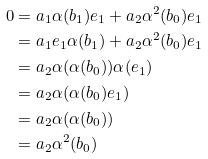<formula> <loc_0><loc_0><loc_500><loc_500>0 & = a _ { 1 } \alpha ( b _ { 1 } ) e _ { 1 } + a _ { 2 } \alpha ^ { 2 } ( b _ { 0 } ) e _ { 1 } \\ & = a _ { 1 } e _ { 1 } \alpha ( b _ { 1 } ) + a _ { 2 } \alpha ^ { 2 } ( b _ { 0 } ) e _ { 1 } \\ & = a _ { 2 } \alpha ( \alpha ( b _ { 0 } ) ) \alpha ( e _ { 1 } ) \\ & = a _ { 2 } \alpha ( \alpha ( b _ { 0 } ) e _ { 1 } ) \\ & = a _ { 2 } \alpha ( \alpha ( b _ { 0 } ) ) \\ & = a _ { 2 } \alpha ^ { 2 } ( b _ { 0 } )</formula> 